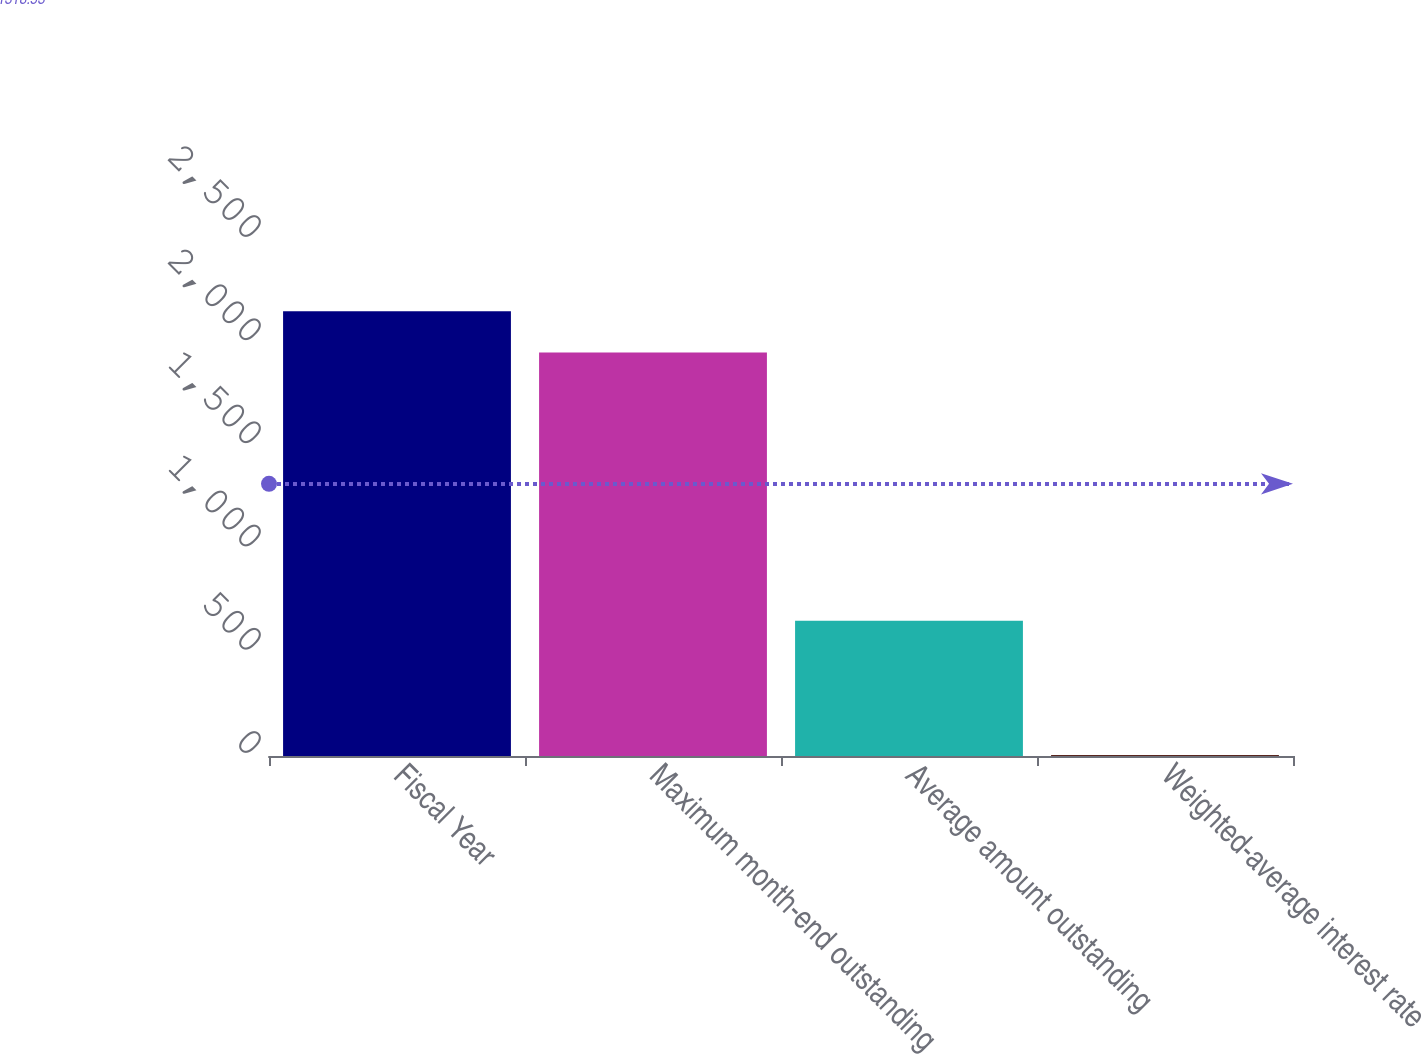Convert chart to OTSL. <chart><loc_0><loc_0><loc_500><loc_500><bar_chart><fcel>Fiscal Year<fcel>Maximum month-end outstanding<fcel>Average amount outstanding<fcel>Weighted-average interest rate<nl><fcel>2155.35<fcel>1955<fcel>655<fcel>4.5<nl></chart> 